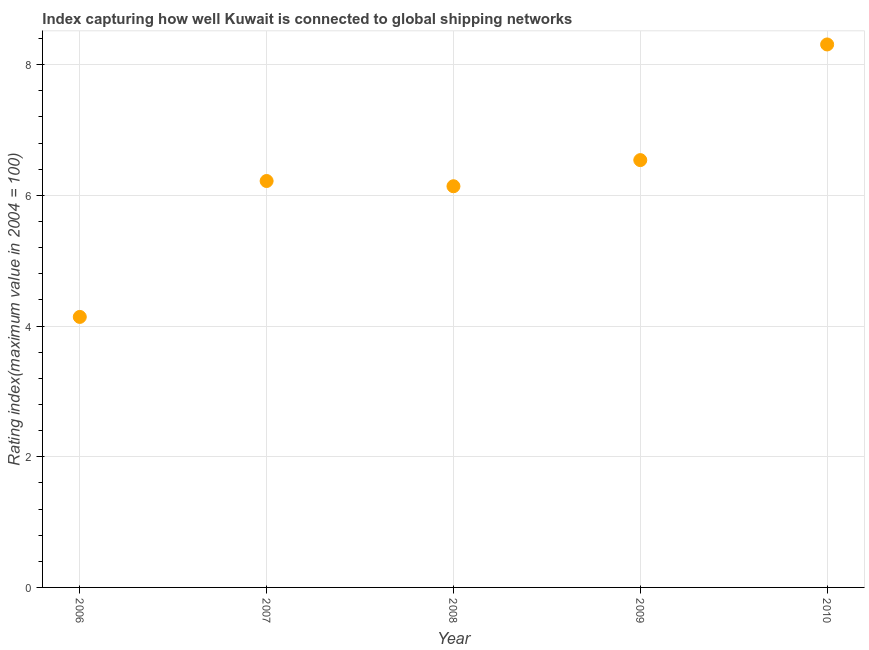What is the liner shipping connectivity index in 2006?
Provide a short and direct response. 4.14. Across all years, what is the maximum liner shipping connectivity index?
Give a very brief answer. 8.31. Across all years, what is the minimum liner shipping connectivity index?
Offer a terse response. 4.14. In which year was the liner shipping connectivity index maximum?
Provide a short and direct response. 2010. What is the sum of the liner shipping connectivity index?
Keep it short and to the point. 31.35. What is the difference between the liner shipping connectivity index in 2007 and 2008?
Make the answer very short. 0.08. What is the average liner shipping connectivity index per year?
Provide a short and direct response. 6.27. What is the median liner shipping connectivity index?
Offer a very short reply. 6.22. What is the ratio of the liner shipping connectivity index in 2008 to that in 2009?
Your response must be concise. 0.94. Is the difference between the liner shipping connectivity index in 2006 and 2010 greater than the difference between any two years?
Provide a succinct answer. Yes. What is the difference between the highest and the second highest liner shipping connectivity index?
Give a very brief answer. 1.77. Is the sum of the liner shipping connectivity index in 2008 and 2009 greater than the maximum liner shipping connectivity index across all years?
Give a very brief answer. Yes. What is the difference between the highest and the lowest liner shipping connectivity index?
Provide a succinct answer. 4.17. In how many years, is the liner shipping connectivity index greater than the average liner shipping connectivity index taken over all years?
Ensure brevity in your answer.  2. Does the liner shipping connectivity index monotonically increase over the years?
Your answer should be very brief. No. How many dotlines are there?
Ensure brevity in your answer.  1. How many years are there in the graph?
Offer a very short reply. 5. Are the values on the major ticks of Y-axis written in scientific E-notation?
Provide a succinct answer. No. Does the graph contain grids?
Provide a short and direct response. Yes. What is the title of the graph?
Offer a very short reply. Index capturing how well Kuwait is connected to global shipping networks. What is the label or title of the Y-axis?
Ensure brevity in your answer.  Rating index(maximum value in 2004 = 100). What is the Rating index(maximum value in 2004 = 100) in 2006?
Your response must be concise. 4.14. What is the Rating index(maximum value in 2004 = 100) in 2007?
Your response must be concise. 6.22. What is the Rating index(maximum value in 2004 = 100) in 2008?
Offer a terse response. 6.14. What is the Rating index(maximum value in 2004 = 100) in 2009?
Offer a very short reply. 6.54. What is the Rating index(maximum value in 2004 = 100) in 2010?
Your answer should be compact. 8.31. What is the difference between the Rating index(maximum value in 2004 = 100) in 2006 and 2007?
Provide a succinct answer. -2.08. What is the difference between the Rating index(maximum value in 2004 = 100) in 2006 and 2009?
Keep it short and to the point. -2.4. What is the difference between the Rating index(maximum value in 2004 = 100) in 2006 and 2010?
Offer a very short reply. -4.17. What is the difference between the Rating index(maximum value in 2004 = 100) in 2007 and 2008?
Your answer should be very brief. 0.08. What is the difference between the Rating index(maximum value in 2004 = 100) in 2007 and 2009?
Your answer should be very brief. -0.32. What is the difference between the Rating index(maximum value in 2004 = 100) in 2007 and 2010?
Ensure brevity in your answer.  -2.09. What is the difference between the Rating index(maximum value in 2004 = 100) in 2008 and 2009?
Offer a terse response. -0.4. What is the difference between the Rating index(maximum value in 2004 = 100) in 2008 and 2010?
Offer a terse response. -2.17. What is the difference between the Rating index(maximum value in 2004 = 100) in 2009 and 2010?
Your answer should be very brief. -1.77. What is the ratio of the Rating index(maximum value in 2004 = 100) in 2006 to that in 2007?
Keep it short and to the point. 0.67. What is the ratio of the Rating index(maximum value in 2004 = 100) in 2006 to that in 2008?
Give a very brief answer. 0.67. What is the ratio of the Rating index(maximum value in 2004 = 100) in 2006 to that in 2009?
Your response must be concise. 0.63. What is the ratio of the Rating index(maximum value in 2004 = 100) in 2006 to that in 2010?
Provide a succinct answer. 0.5. What is the ratio of the Rating index(maximum value in 2004 = 100) in 2007 to that in 2008?
Offer a terse response. 1.01. What is the ratio of the Rating index(maximum value in 2004 = 100) in 2007 to that in 2009?
Offer a terse response. 0.95. What is the ratio of the Rating index(maximum value in 2004 = 100) in 2007 to that in 2010?
Ensure brevity in your answer.  0.75. What is the ratio of the Rating index(maximum value in 2004 = 100) in 2008 to that in 2009?
Make the answer very short. 0.94. What is the ratio of the Rating index(maximum value in 2004 = 100) in 2008 to that in 2010?
Provide a succinct answer. 0.74. What is the ratio of the Rating index(maximum value in 2004 = 100) in 2009 to that in 2010?
Provide a short and direct response. 0.79. 